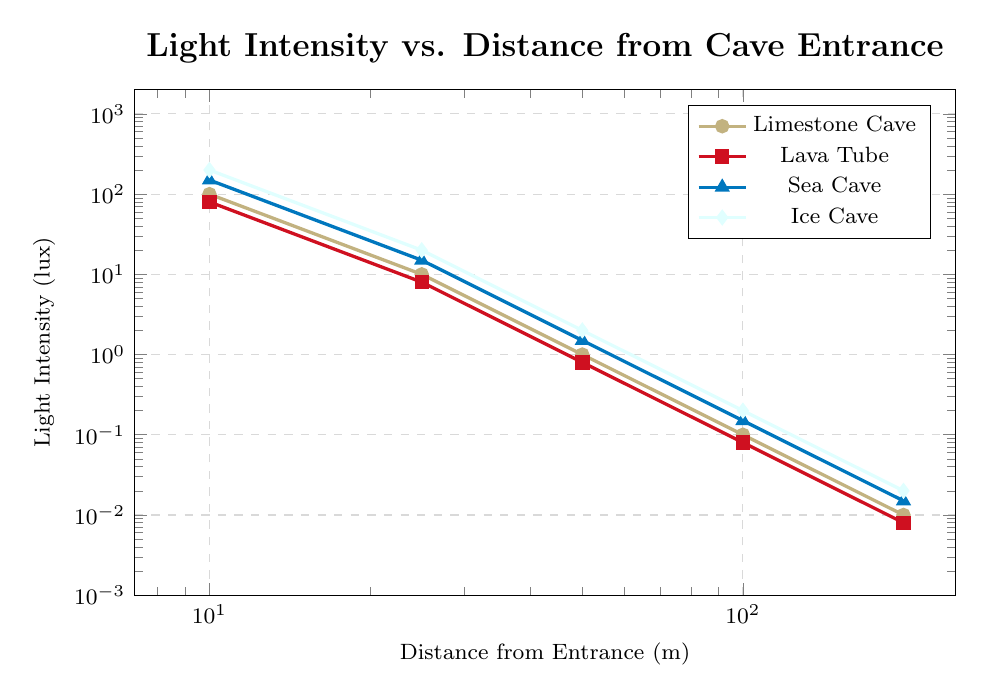What is the range of light intensity levels observed in the Limestone Cave from the entrance to 200 meters inside the cave? To find the range, identify the highest and lowest light intensity values. The highest is 1000 lux at 0 meters and the lowest is 0.01 lux at 200 meters. The range is then calculated by subtracting the lowest value from the highest: 1000 - 0.01 = 999.99 lux.
Answer: 999.99 lux Which cave type shows the highest light intensity at the entrance? Compare the light intensity values at the entrance (0 meters) for each cave type. Limestone Cave has 1000 lux, Lava Tube has 900 lux, Sea Cave has 1200 lux, and Ice Cave has 1500 lux. The highest value is 1500 lux for the Ice Cave.
Answer: Ice Cave In which cave type does the light intensity drop below 1 lux at the shortest distance from the entrance? Examine the distances where each cave type's light intensity falls below 1 lux. Limestone Cave reaches 1 lux at 50 meters, Lava Tube at 50 meters, Sea Cave at 50 meters, and Ice Cave at 50 meters as well. Since all reach this threshold at the same distance, there is no single cave type that achieves it at a shorter distance than the others.
Answer: Limestone Cave, Lava Tube, Sea Cave, Ice Cave What is the percentage decrease in light intensity from 0 meters to 100 meters in a Sea Cave? Calculate the percentage decrease from 0 meters (1200 lux) to 100 meters (0.15 lux) in a Sea Cave. The decrease is found by (1200 - 0.15) = 1199.85 lux. The percentage decrease is (1199.85 / 1200) * 100%.
Answer: 99.99% Compare the light intensity at 50 meters from the entrance for all cave types. Which cave type has the highest intensity at this distance? Check the light intensity values at 50 meters for each cave type. Limestone Cave has 1 lux, Lava Tube has 0.8 lux, Sea Cave has 1.5 lux, and Ice Cave has 2 lux. Ice Cave with 2 lux has the highest light intensity.
Answer: Ice Cave Which cave type experiences a steeper decline in light intensity from 10 meters to 25 meters? Calculate the rate of decline in light intensity between 10 meters and 25 meters for each cave type: Limestone Cave (100 to 10 lux), Lava Tube (80 to 8 lux), Sea Cave (150 to 15 lux), and Ice Cave (200 to 20 lux). The decline for each is 90, 72, 135, and 180 lux, respectively. The highest decline is 180 lux for Ice Cave.
Answer: Ice Cave Determine the average light intensity across all measured distances in the Lava Tube. Sum the light intensity values for Lava Tube at all measured distances: 900, 80, 8, 0.8, 0.08, 0.008. The sum is 988.888 lux. Divide by the number of values (6) to find the average: 988.888 / 6.
Answer: 164.81 lux 